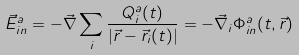Convert formula to latex. <formula><loc_0><loc_0><loc_500><loc_500>\vec { E } _ { i n } ^ { a } = - \vec { \nabla } \sum _ { i } \frac { Q ^ { a } _ { i } ( t ) } { | \vec { r } - \vec { r } _ { i } ( t ) | } = - \vec { \nabla } _ { i } \Phi ^ { a } _ { i n } ( t , \vec { r } )</formula> 